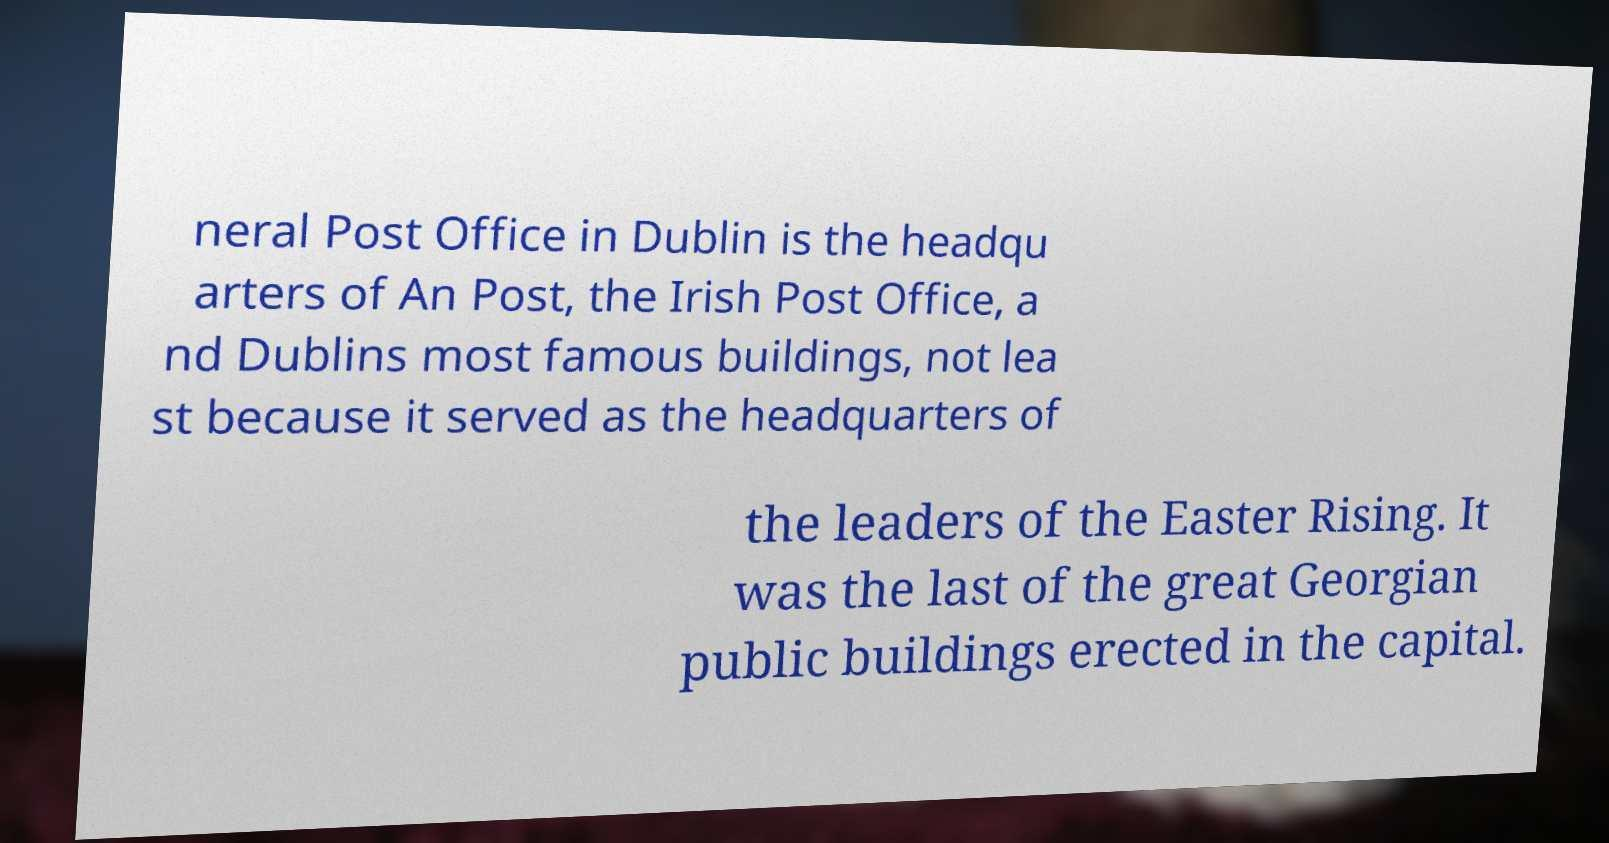Please identify and transcribe the text found in this image. neral Post Office in Dublin is the headqu arters of An Post, the Irish Post Office, a nd Dublins most famous buildings, not lea st because it served as the headquarters of the leaders of the Easter Rising. It was the last of the great Georgian public buildings erected in the capital. 